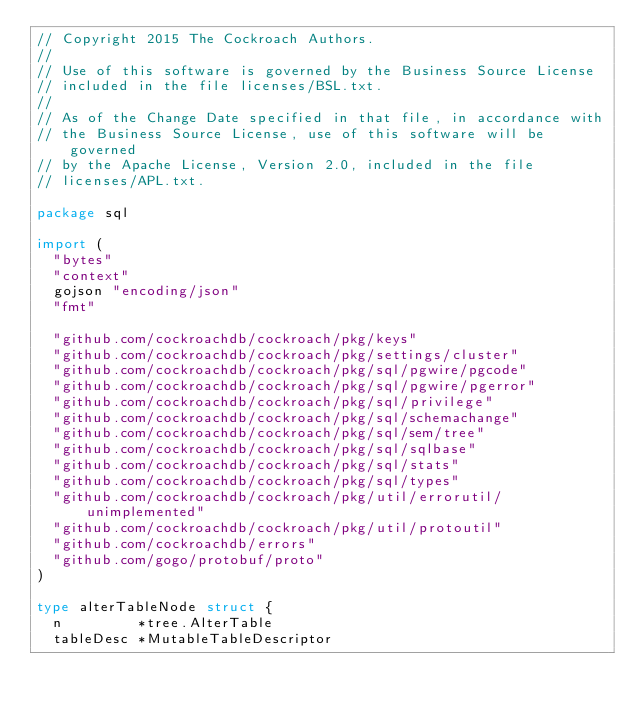Convert code to text. <code><loc_0><loc_0><loc_500><loc_500><_Go_>// Copyright 2015 The Cockroach Authors.
//
// Use of this software is governed by the Business Source License
// included in the file licenses/BSL.txt.
//
// As of the Change Date specified in that file, in accordance with
// the Business Source License, use of this software will be governed
// by the Apache License, Version 2.0, included in the file
// licenses/APL.txt.

package sql

import (
	"bytes"
	"context"
	gojson "encoding/json"
	"fmt"

	"github.com/cockroachdb/cockroach/pkg/keys"
	"github.com/cockroachdb/cockroach/pkg/settings/cluster"
	"github.com/cockroachdb/cockroach/pkg/sql/pgwire/pgcode"
	"github.com/cockroachdb/cockroach/pkg/sql/pgwire/pgerror"
	"github.com/cockroachdb/cockroach/pkg/sql/privilege"
	"github.com/cockroachdb/cockroach/pkg/sql/schemachange"
	"github.com/cockroachdb/cockroach/pkg/sql/sem/tree"
	"github.com/cockroachdb/cockroach/pkg/sql/sqlbase"
	"github.com/cockroachdb/cockroach/pkg/sql/stats"
	"github.com/cockroachdb/cockroach/pkg/sql/types"
	"github.com/cockroachdb/cockroach/pkg/util/errorutil/unimplemented"
	"github.com/cockroachdb/cockroach/pkg/util/protoutil"
	"github.com/cockroachdb/errors"
	"github.com/gogo/protobuf/proto"
)

type alterTableNode struct {
	n         *tree.AlterTable
	tableDesc *MutableTableDescriptor</code> 